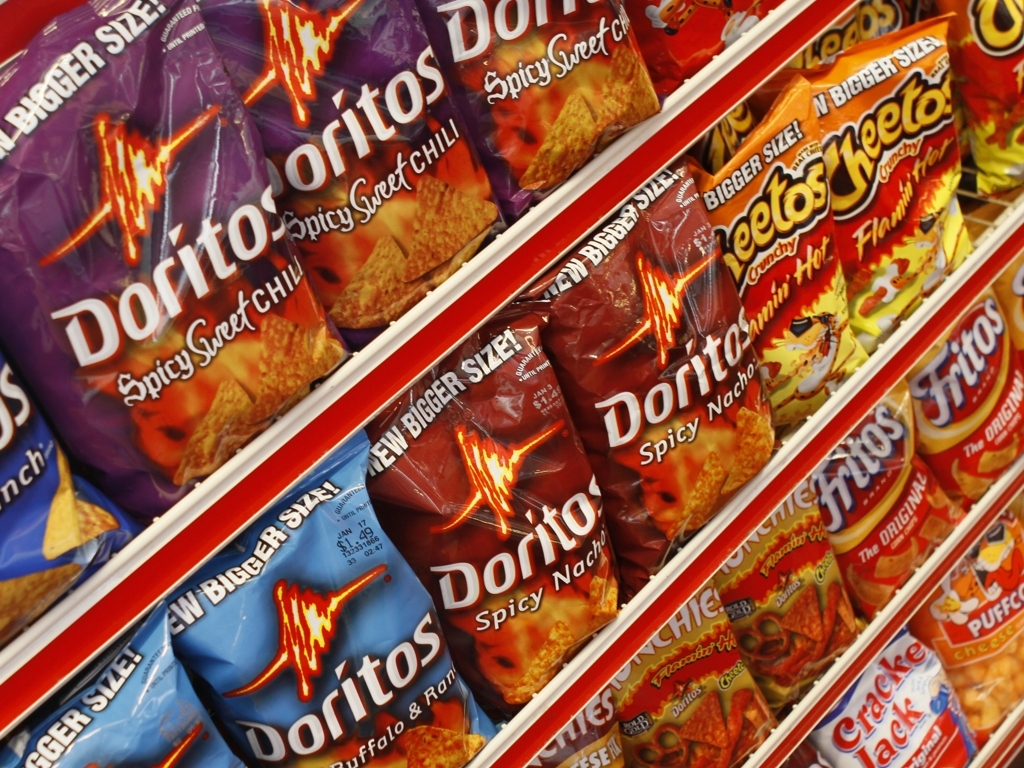Can you tell if there are any promotional offers mentioned on these snack bags? From the visible portion of the packaging, there do not appear to be any promotional offers. The bags seem to focus more on the brand and flavor representation. 